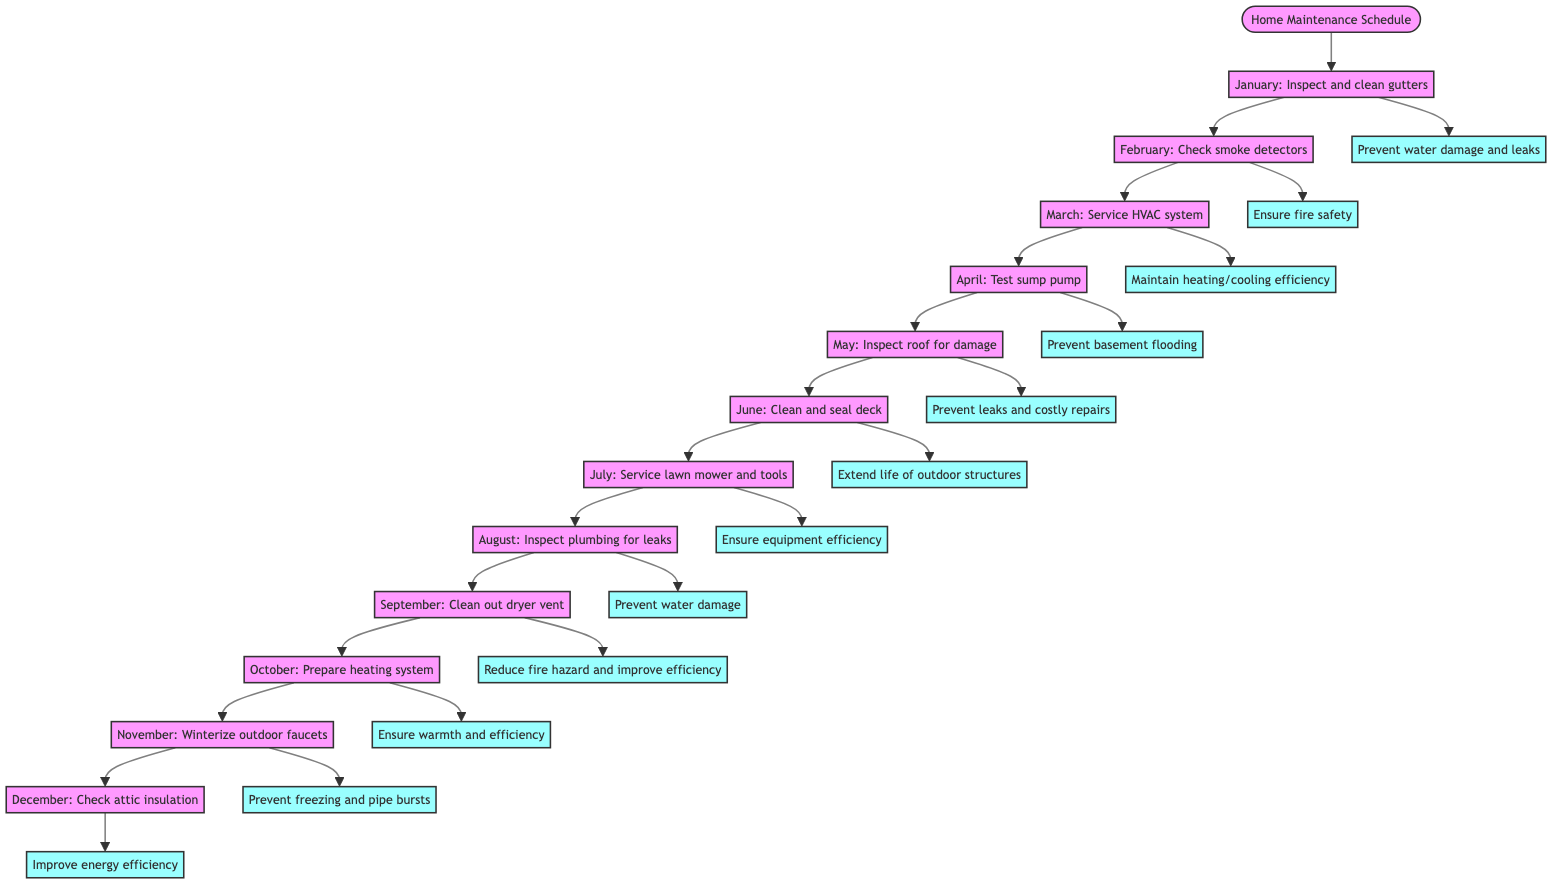What is the maintenance task for March? The diagram flows to the March node, which indicates the task is to "Service the HVAC system."
Answer: Service the HVAC system How many tasks are listed in the schedule? By counting the nodes from January to December, we find there are 12 distinct maintenance tasks represented.
Answer: 12 What is the outcome of the task in June? Following the flow to June, the outcome stated is "Extend life of outdoor structures."
Answer: Extend life of outdoor structures Which month's task focuses on fire safety? The flow to February shows the task "Check smoke detectors," which is related to ensuring fire safety.
Answer: February What is the relationship between the February task and its outcome? The flow connects February's task of checking smoke detectors directly to its outcome, which is to "Ensure fire safety."
Answer: Ensure fire safety What is the task for November? November's node displays the task "Winterize outdoor faucets."
Answer: Winterize outdoor faucets Which two months are related to preventing water damage? By examining the tasks in both January and August, they address water damage: January (Inspect and clean gutters) and August (Inspect plumbing for leaks).
Answer: January and August Which task is meant to prevent flooding? The task that specifically aims to prevent flooding is in April, which is "Test sump pump."
Answer: Test sump pump What is the outcome linked with the October task? The task for October leads to the outcome "Ensure warmth and efficiency," which relates to preparing the heating system for winter.
Answer: Ensure warmth and efficiency 